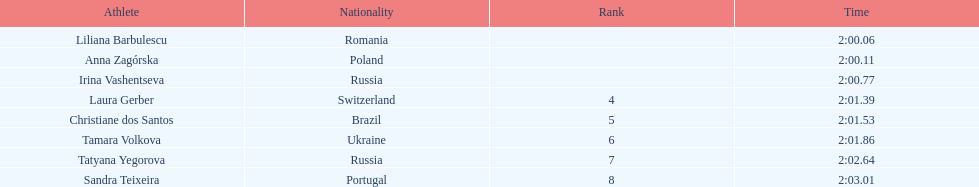What is the number of russian participants in this set of semifinals? 2. 